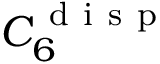Convert formula to latex. <formula><loc_0><loc_0><loc_500><loc_500>C _ { 6 } ^ { d i s p }</formula> 